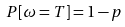Convert formula to latex. <formula><loc_0><loc_0><loc_500><loc_500>P [ \omega = T ] = 1 - p</formula> 